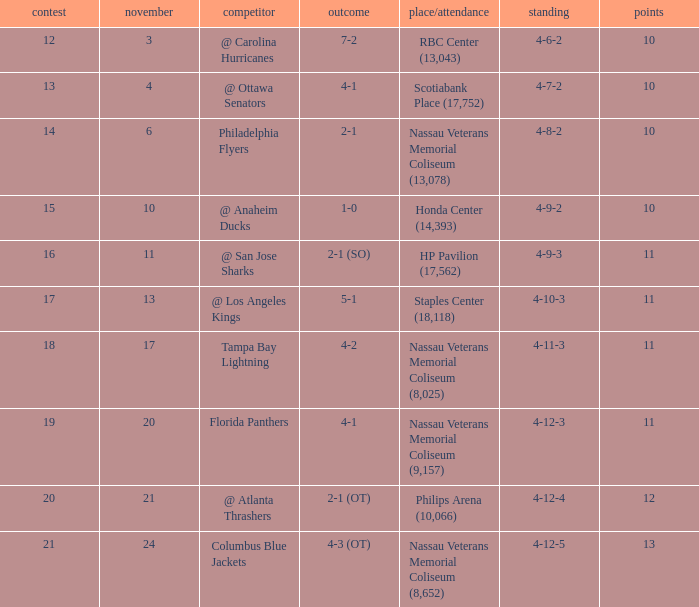Write the full table. {'header': ['contest', 'november', 'competitor', 'outcome', 'place/attendance', 'standing', 'points'], 'rows': [['12', '3', '@ Carolina Hurricanes', '7-2', 'RBC Center (13,043)', '4-6-2', '10'], ['13', '4', '@ Ottawa Senators', '4-1', 'Scotiabank Place (17,752)', '4-7-2', '10'], ['14', '6', 'Philadelphia Flyers', '2-1', 'Nassau Veterans Memorial Coliseum (13,078)', '4-8-2', '10'], ['15', '10', '@ Anaheim Ducks', '1-0', 'Honda Center (14,393)', '4-9-2', '10'], ['16', '11', '@ San Jose Sharks', '2-1 (SO)', 'HP Pavilion (17,562)', '4-9-3', '11'], ['17', '13', '@ Los Angeles Kings', '5-1', 'Staples Center (18,118)', '4-10-3', '11'], ['18', '17', 'Tampa Bay Lightning', '4-2', 'Nassau Veterans Memorial Coliseum (8,025)', '4-11-3', '11'], ['19', '20', 'Florida Panthers', '4-1', 'Nassau Veterans Memorial Coliseum (9,157)', '4-12-3', '11'], ['20', '21', '@ Atlanta Thrashers', '2-1 (OT)', 'Philips Arena (10,066)', '4-12-4', '12'], ['21', '24', 'Columbus Blue Jackets', '4-3 (OT)', 'Nassau Veterans Memorial Coliseum (8,652)', '4-12-5', '13']]} What is the least amount of points? 10.0. 